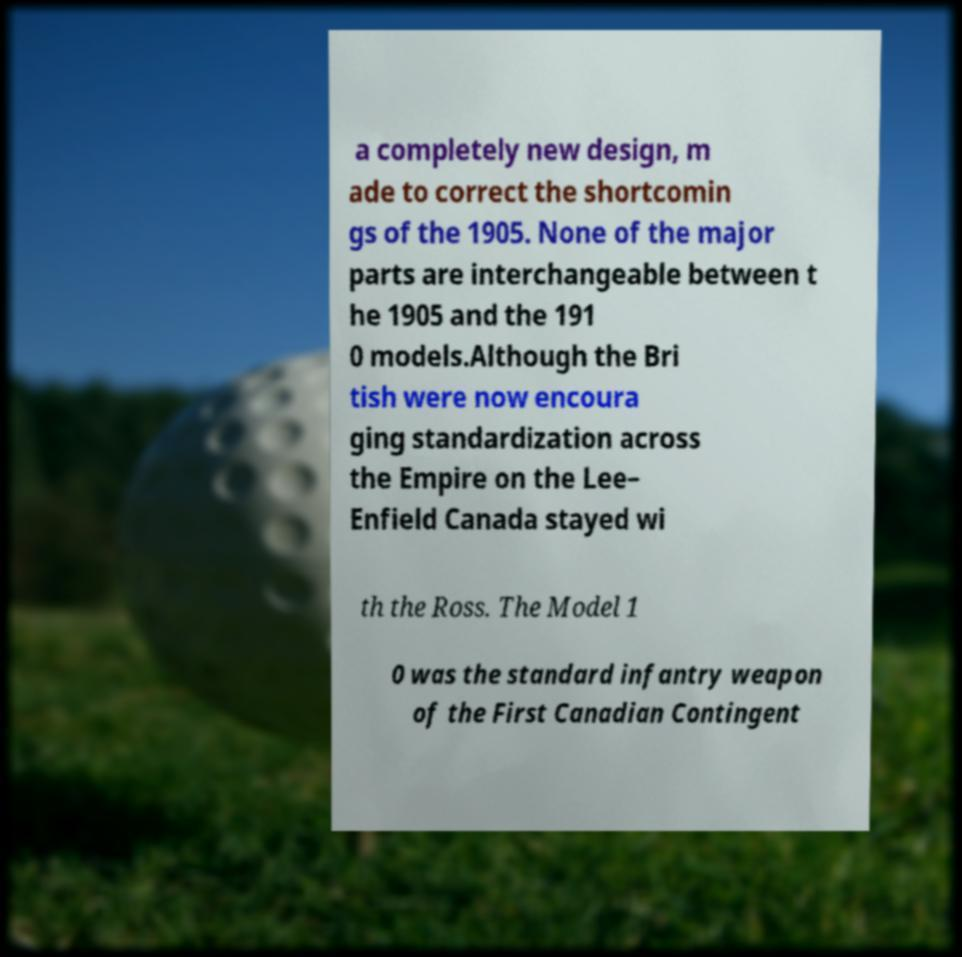Can you read and provide the text displayed in the image?This photo seems to have some interesting text. Can you extract and type it out for me? a completely new design, m ade to correct the shortcomin gs of the 1905. None of the major parts are interchangeable between t he 1905 and the 191 0 models.Although the Bri tish were now encoura ging standardization across the Empire on the Lee– Enfield Canada stayed wi th the Ross. The Model 1 0 was the standard infantry weapon of the First Canadian Contingent 